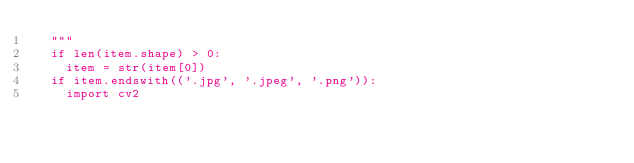Convert code to text. <code><loc_0><loc_0><loc_500><loc_500><_Python_>  """
  if len(item.shape) > 0:
    item = str(item[0])
  if item.endswith(('.jpg', '.jpeg', '.png')):
    import cv2</code> 